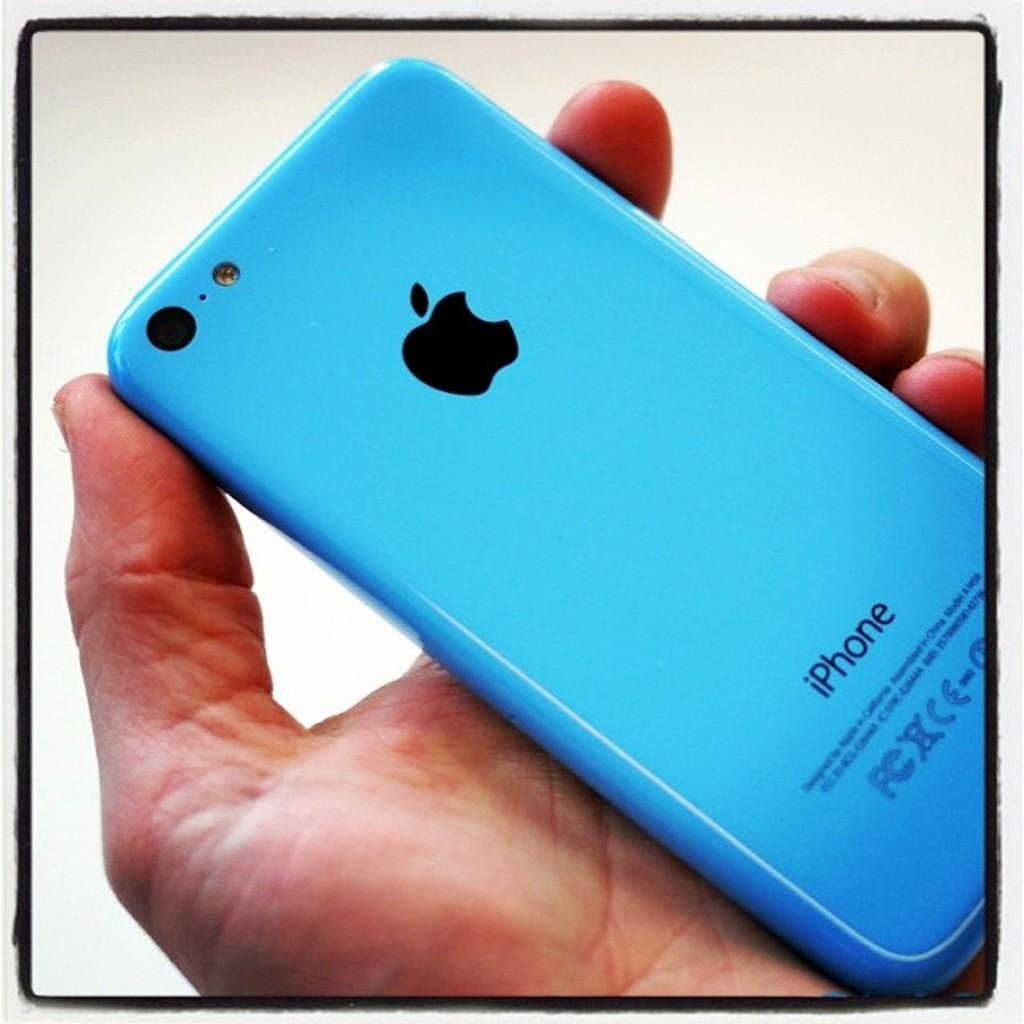<image>
Provide a brief description of the given image. A person holds a blue iPhone in their outstretched palm. 